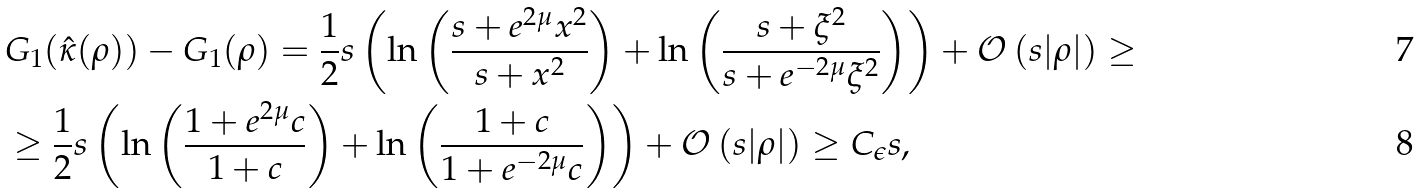<formula> <loc_0><loc_0><loc_500><loc_500>& G _ { 1 } ( \hat { \kappa } ( \rho ) ) - G _ { 1 } ( \rho ) = \frac { 1 } { 2 } s \left ( \ln \left ( \frac { s + e ^ { 2 \mu } x ^ { 2 } } { s + x ^ { 2 } } \right ) + \ln \left ( \frac { s + \xi ^ { 2 } } { s + e ^ { - 2 \mu } \xi ^ { 2 } } \right ) \right ) + { \mathcal { O } } \left ( s | \rho | \right ) \geq \\ & \geq \frac { 1 } { 2 } s \left ( \ln \left ( \frac { 1 + e ^ { 2 \mu } c } { 1 + c } \right ) + \ln \left ( \frac { 1 + c } { 1 + e ^ { - 2 \mu } c } \right ) \right ) + { \mathcal { O } } \left ( s | \rho | \right ) \geq C _ { \epsilon } s ,</formula> 